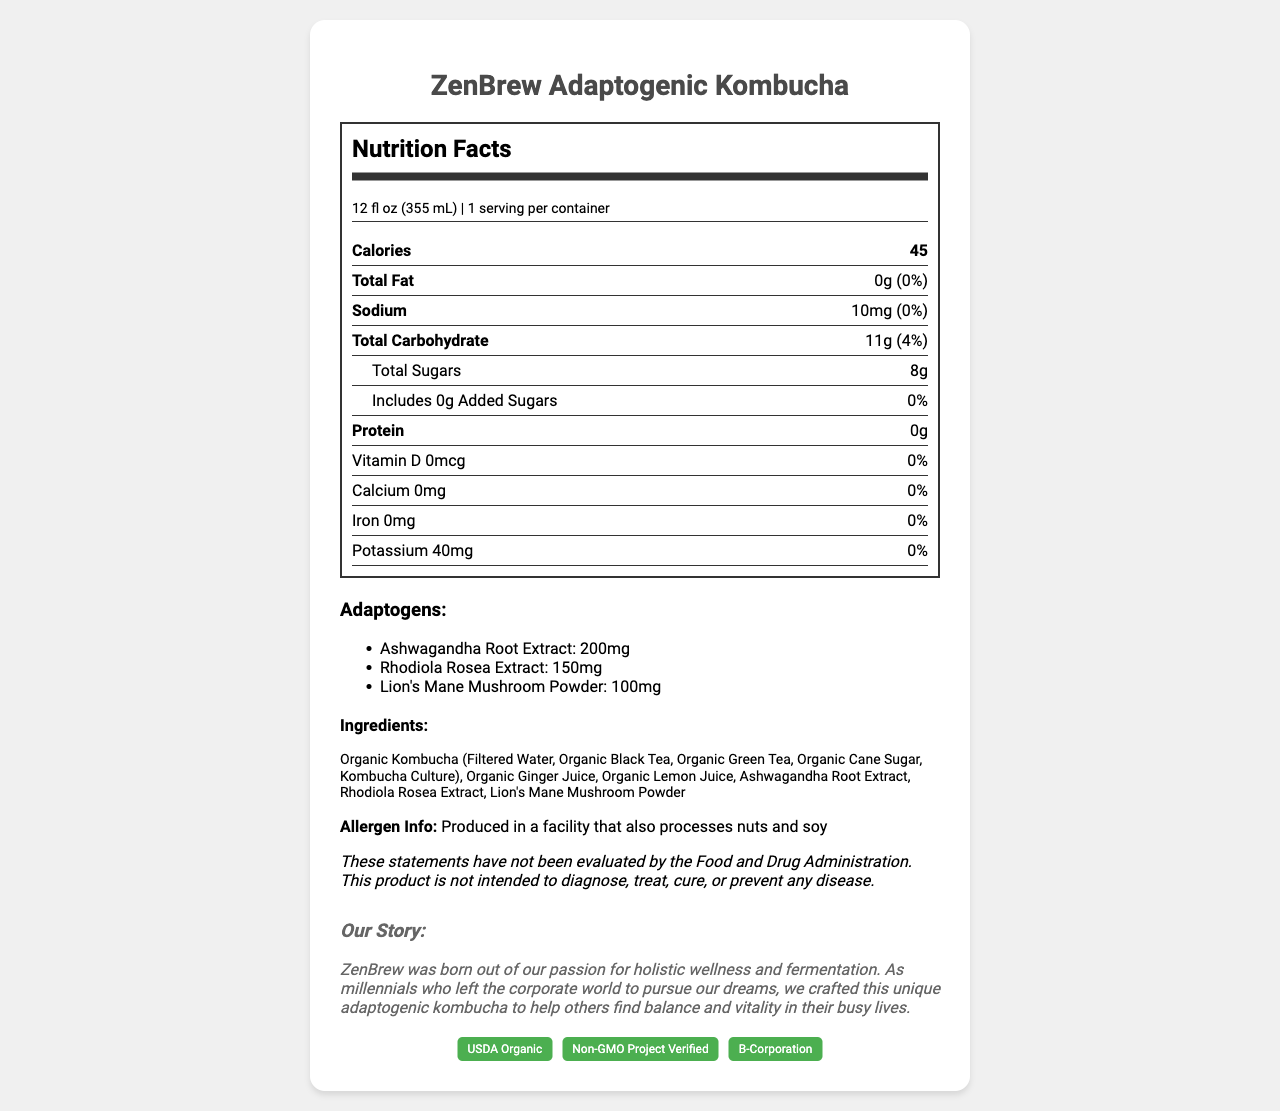what is the serving size of ZenBrew Adaptogenic Kombucha? The serving size is clearly stated on the label as "12 fl oz (355 mL)".
Answer: 12 fl oz (355 mL) how many calories are in one serving of the product? The nutrition facts label lists the calories for one serving as 45.
Answer: 45 which adaptogen has the highest amount in ZenBrew Adaptogenic Kombucha? The adaptogen amounts are listed, and Ashwagandha Root Extract has the highest amount with 200mg.
Answer: Ashwagandha Root Extract what is the daily value percentage for total fat? The daily value percentage for total fat is listed as 0% on the nutrition facts label.
Answer: 0% does the product contain any added sugars? The label states that there are 0g of added sugars.
Answer: No what are the certifications ZenBrew Adaptogenic Kombucha has received? These certifications are listed clearly under the certifications section on the label.
Answer: USDA Organic, Non-GMO Project Verified, B-Corporation what is the amount of protein in one serving? The amount of protein per serving is indicated as 0g on the label.
Answer: 0g how many servings are in one container? There is 1 serving per container, as stated on the label.
Answer: 1 which sodium content is correct for ZenBrew Adaptogenic Kombucha? (5mg, 10mg, 15mg, 20mg) According to the label, the sodium content is 10mg per serving.
Answer: 10mg what ingredient is not specifically mentioned on the label? A. Organic Ginger Juice B. Rhodiola Rosea Extract C. Organic Kombucha D. Turmeric Powder The label does not list Turmeric Powder as an ingredient.
Answer: D. Turmeric Powder does ZenBrew Adaptogenic Kombucha contain any dairy? The ingredients listed do not include any dairy products, and there’s no indication of dairy in the allergen info.
Answer: No please summarize the nutritional and brand information presented on the label. This explanation encompasses both the nutritional facts and the brand story, offering a comprehensive overview of the product.
Answer: ZenBrew Adaptogenic Kombucha is an artisanal, small-batch beverage with 45 calories per 12 fl oz serving. It contains no fat or protein, 10mg of sodium, and 11g of carbohydrates, including 8g of sugars with 0g added sugars. It is infused with adaptogens like Ashwagandha Root Extract (200mg), Rhodiola Rosea Extract (150mg), and Lion's Mane Mushroom Powder (100mg). The product is made with organic ingredients, is USDA Organic, Non-GMO Project Verified, and a B-Corporation. The brand's story highlights their commitment to holistic wellness and fermentation, aiming to balance and revitalize busy lives. how much calcium does ZenBrew Adaptogenic Kombucha contain? The label indicates that the product contains 0mg of calcium.
Answer: 0mg can I find the production date on the label? The production date is not provided in the visual information on the label.
Answer: No does the product contain organic ingredients? The ingredients listed include “Organic” before each item, indicating that they are organic.
Answer: Yes is ZenBrew Adaptogenic Kombucha intended to diagnose or treat any disease? The disclaimer clearly states that the product is not intended to diagnose, treat, cure, or prevent any disease.
Answer: No 